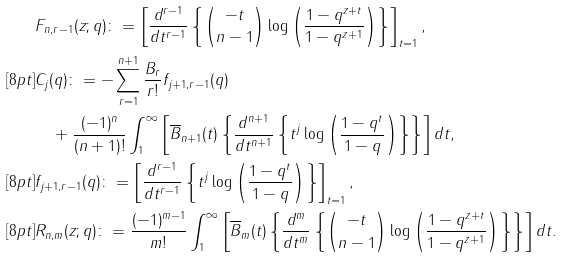<formula> <loc_0><loc_0><loc_500><loc_500>& F _ { n , r - 1 } ( z ; q ) \colon = \left [ \frac { d ^ { r - 1 } } { d t ^ { r - 1 } } \left \{ \binom { - t } { n - 1 } \log \left ( \frac { 1 - q ^ { z + t } } { 1 - q ^ { z + 1 } } \right ) \right \} \right ] _ { t = 1 } , \\ [ 8 p t ] & C _ { j } ( q ) \colon = - \sum _ { r = 1 } ^ { n + 1 } \frac { B _ { r } } { r ! } f _ { j + 1 , r - 1 } ( q ) \\ & \quad + \frac { ( - 1 ) ^ { n } } { ( n + 1 ) ! } \int _ { 1 } ^ { \infty } \left [ \overline { B } _ { n + 1 } ( t ) \left \{ \frac { d ^ { n + 1 } } { d t ^ { n + 1 } } \left \{ t ^ { j } \log \left ( \frac { 1 - q ^ { t } } { 1 - q } \right ) \right \} \right \} \right ] d t , \\ [ 8 p t ] & f _ { j + 1 , r - 1 } ( q ) \colon = \left [ \frac { d ^ { r - 1 } } { d t ^ { r - 1 } } \left \{ t ^ { j } \log \left ( \frac { 1 - q ^ { t } } { 1 - q } \right ) \right \} \right ] _ { t = 1 } , \\ [ 8 p t ] & R _ { n , m } ( z ; q ) \colon = \frac { ( - 1 ) ^ { m - 1 } } { m ! } \int _ { 1 } ^ { \infty } \left [ \overline { B } _ { m } ( t ) \left \{ \frac { d ^ { m } } { d t ^ { m } } \left \{ \binom { - t } { n - 1 } \log \left ( \frac { 1 - q ^ { z + t } } { 1 - q ^ { z + 1 } } \right ) \right \} \right \} \right ] d t .</formula> 